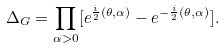Convert formula to latex. <formula><loc_0><loc_0><loc_500><loc_500>\Delta _ { G } = \prod _ { \alpha > 0 } [ e ^ { \frac { i } { 2 } ( \theta , \alpha ) } - e ^ { - \frac { i } { 2 } ( \theta , \alpha ) } ] .</formula> 